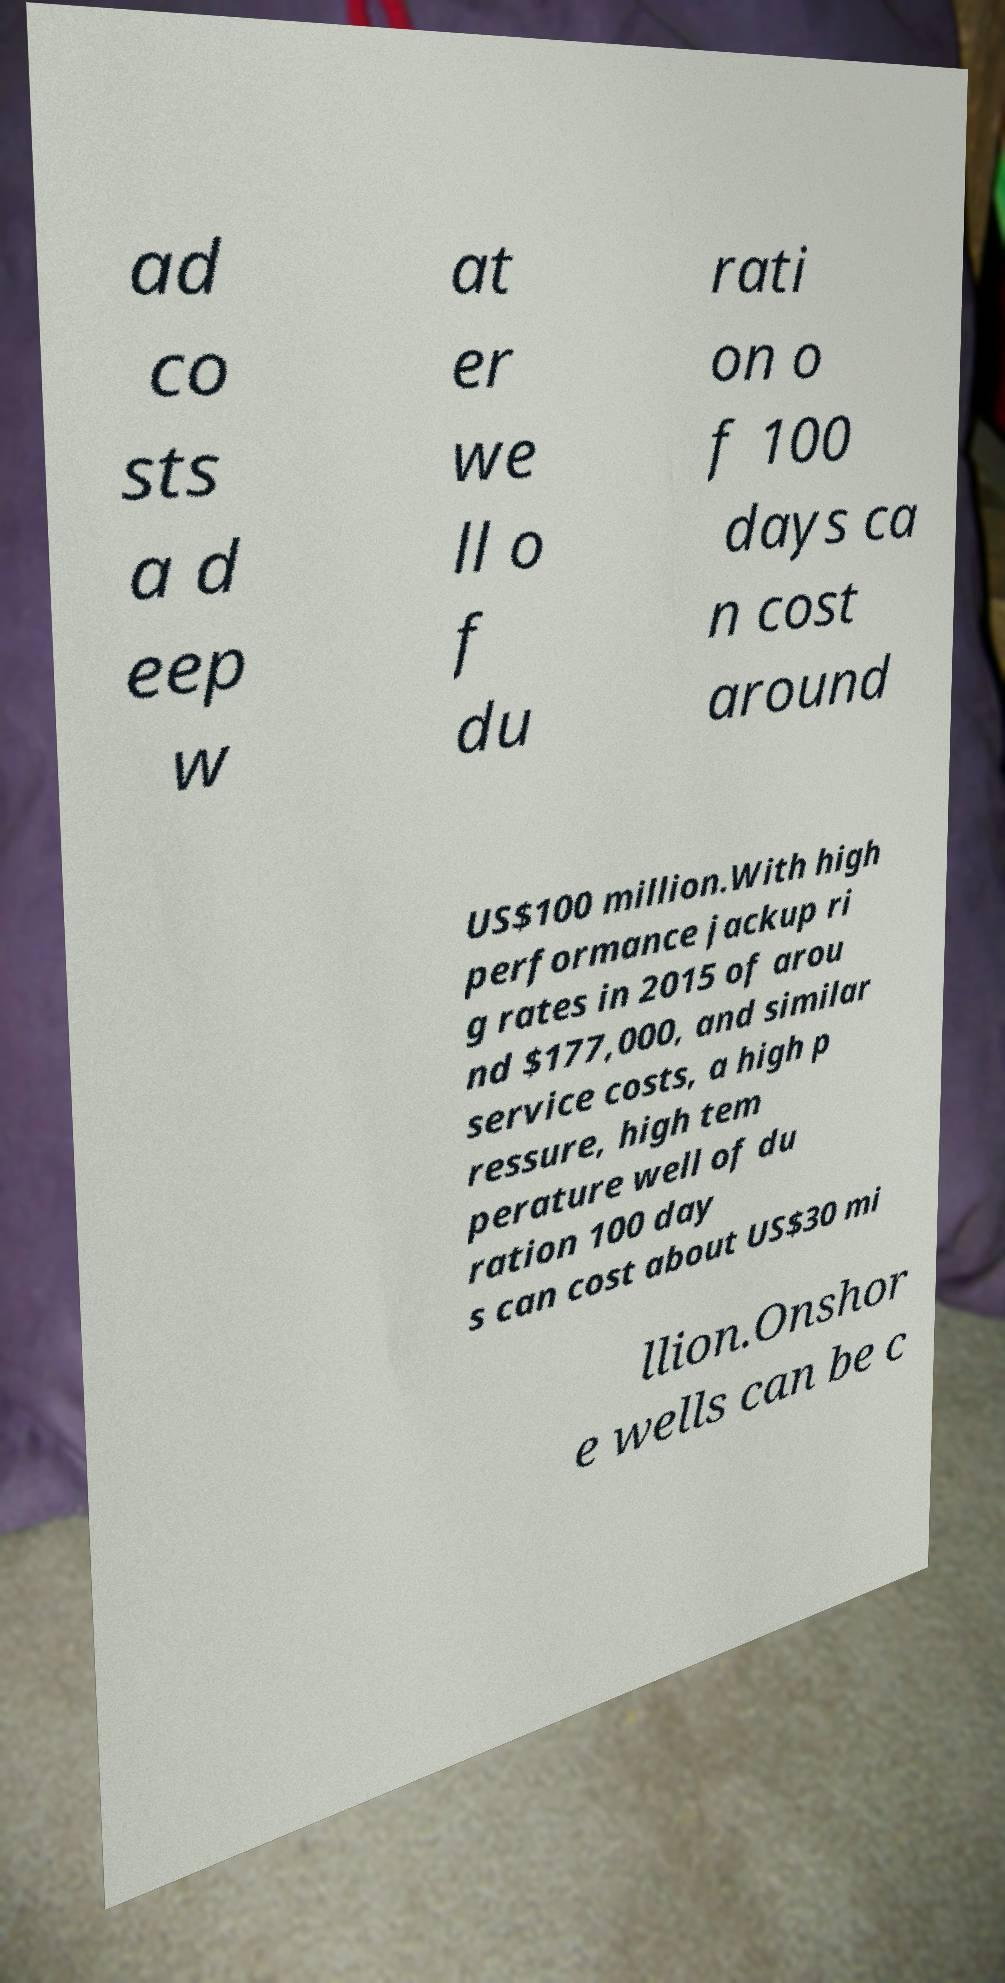There's text embedded in this image that I need extracted. Can you transcribe it verbatim? ad co sts a d eep w at er we ll o f du rati on o f 100 days ca n cost around US$100 million.With high performance jackup ri g rates in 2015 of arou nd $177,000, and similar service costs, a high p ressure, high tem perature well of du ration 100 day s can cost about US$30 mi llion.Onshor e wells can be c 